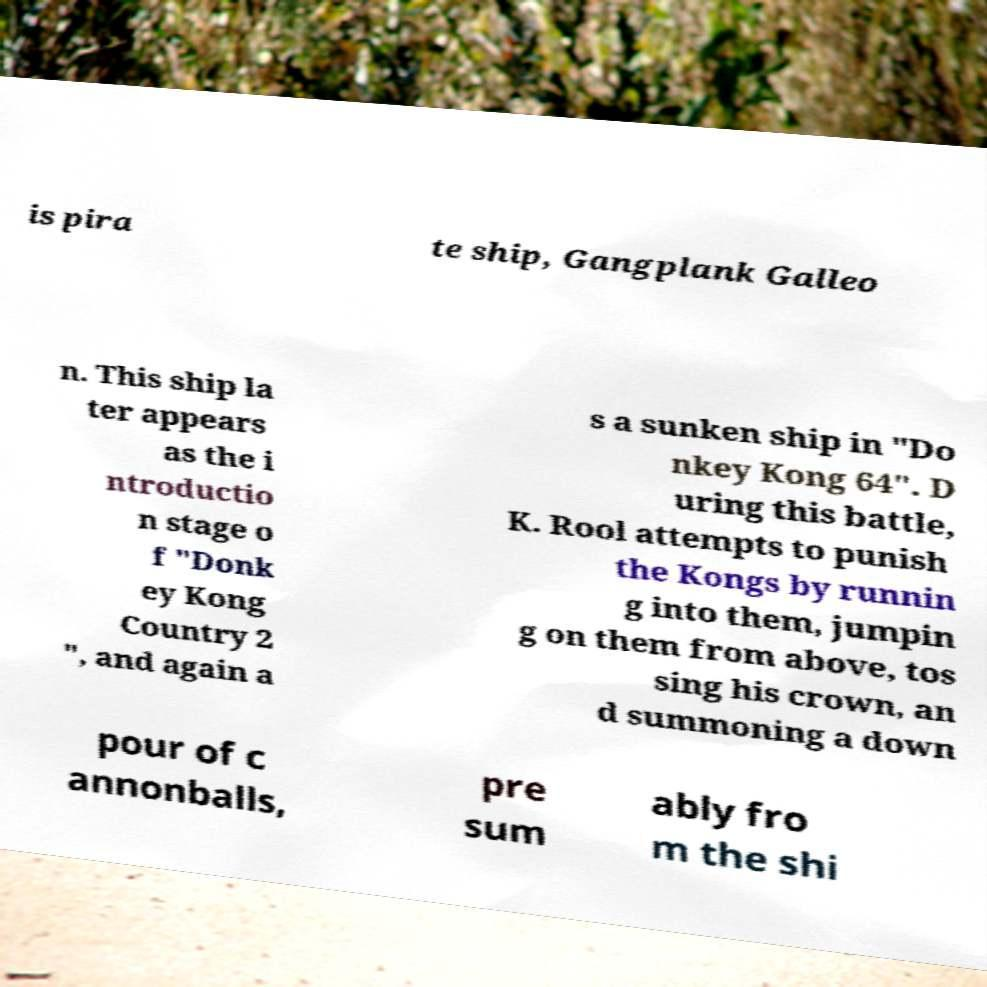Could you assist in decoding the text presented in this image and type it out clearly? is pira te ship, Gangplank Galleo n. This ship la ter appears as the i ntroductio n stage o f "Donk ey Kong Country 2 ", and again a s a sunken ship in "Do nkey Kong 64". D uring this battle, K. Rool attempts to punish the Kongs by runnin g into them, jumpin g on them from above, tos sing his crown, an d summoning a down pour of c annonballs, pre sum ably fro m the shi 